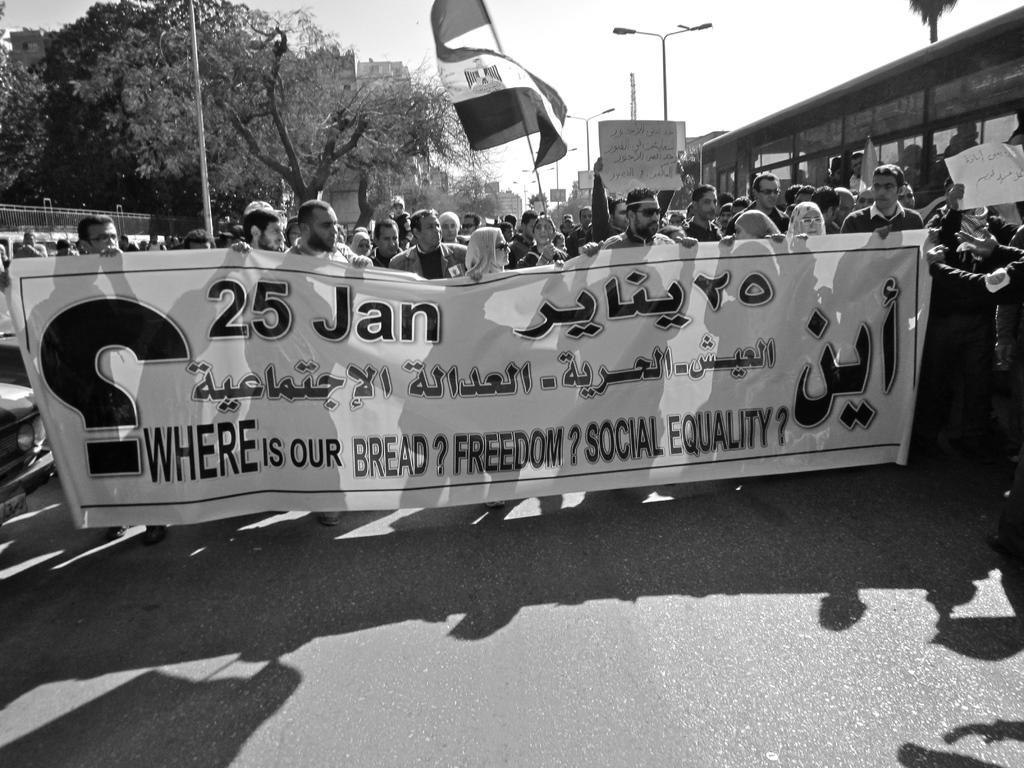Please provide a concise description of this image. In the picture I can see people among them the people in the front are holding banner on which I can see there is something written on it. Some of them are holding flag and placards. In the background I can see trees, street lights, fence, the sky and some other objects. This picture is black and white in color. 